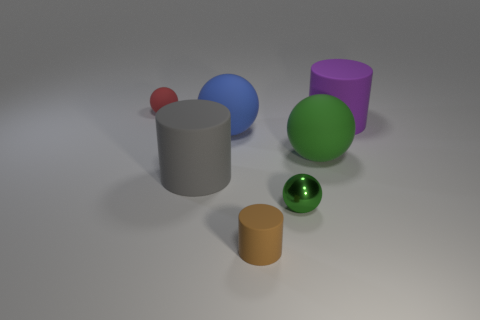Subtract all small cylinders. How many cylinders are left? 2 Add 1 large blue spheres. How many objects exist? 8 Subtract all cyan cubes. How many green spheres are left? 2 Subtract all red balls. How many balls are left? 3 Subtract 2 balls. How many balls are left? 2 Add 7 small blue cylinders. How many small blue cylinders exist? 7 Subtract 0 purple spheres. How many objects are left? 7 Subtract all spheres. How many objects are left? 3 Subtract all yellow balls. Subtract all gray cubes. How many balls are left? 4 Subtract all large balls. Subtract all big purple things. How many objects are left? 4 